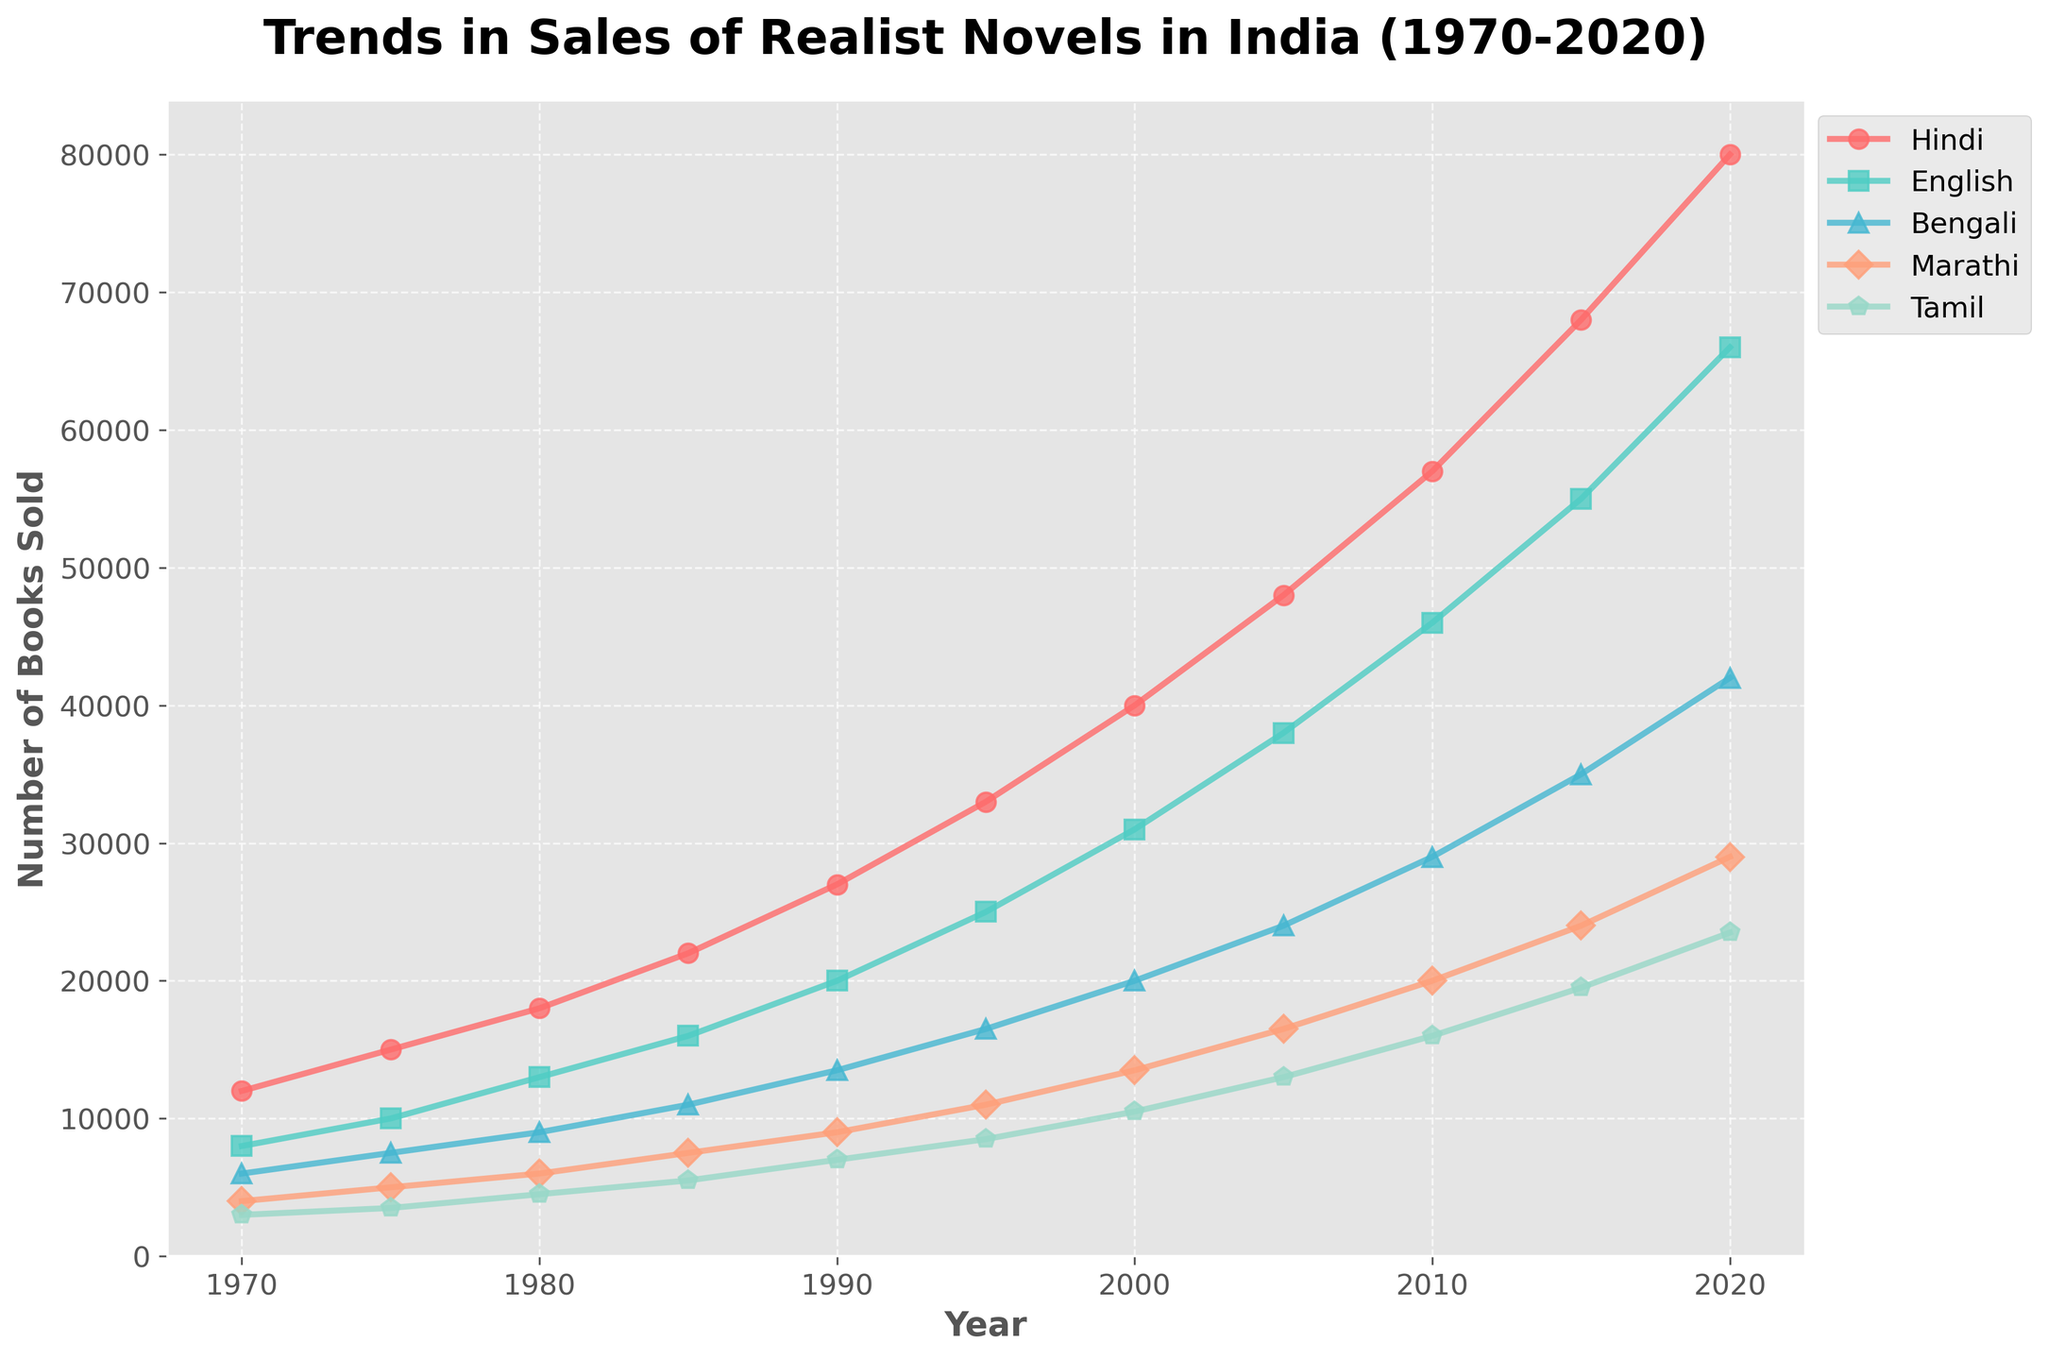What is the trend for Hindi novels over the years? The trend for Hindi novels has been increasing steadily from 12000 in 1970 to 80000 in 2020, showing consistent growth.
Answer: Increasing Which language had the highest sales in 2020? By looking at the figure, Hindi novels had the highest sales in 2020 with 80000 books sold.
Answer: Hindi Among the languages shown, which had the lowest sales in 1970? The figure shows that Tamil had the lowest sales in 1970 with 3000 books sold.
Answer: Tamil How much more did English novels sell compared to Bengali novels in 2000? In 2000, English novels sold 31000 copies and Bengali novels sold 20000 copies. The difference is 31000 - 20000 = 11000.
Answer: 11000 What is the average number of Bengali novels sold per decade from 1970 to 2020? Add the sales figures for Bengali novels across the decades (6000 + 7500 + 9000 + 11000 + 13500 + 16500 + 20000 + 24000 + 29000 + 35000 + 42000) and divide by the number of decades, which is 11. The sum is 215,500. Thus, 215500 / 11 ≈ 19500.
Answer: 19500 Which language had the highest growth rate from 1970 to 2020? Compare the initial and final sales for each language. Hindi: 12000 to 80000, English: 8000 to 66000, Bengali: 6000 to 42000, Marathi: 4000 to 29000, Tamil: 3000 to 23500. Hindi had the highest growth from 12000 to 80000.
Answer: Hindi How has the sales trend for Marathi novels changed from 1990 to 2020? Marathi novels' sales increased from 9000 in 1990 to 29000 in 2020, indicating a steady increase over the period.
Answer: Steady increase Which language saw the least growth from 1970 to 1980? Hindi went from 12000 to 18000, English from 8000 to 13000, Bengali from 6000 to 9000, Marathi from 4000 to 6000, and Tamil from 3000 to 4500. Tamil had the smallest increase (1500 books).
Answer: Tamil What year did English novels surpass 50000 copies sold? Referring to the figure, English novels surpassed 50000 copies sold in 2015 when sales reached 55000.
Answer: 2015 